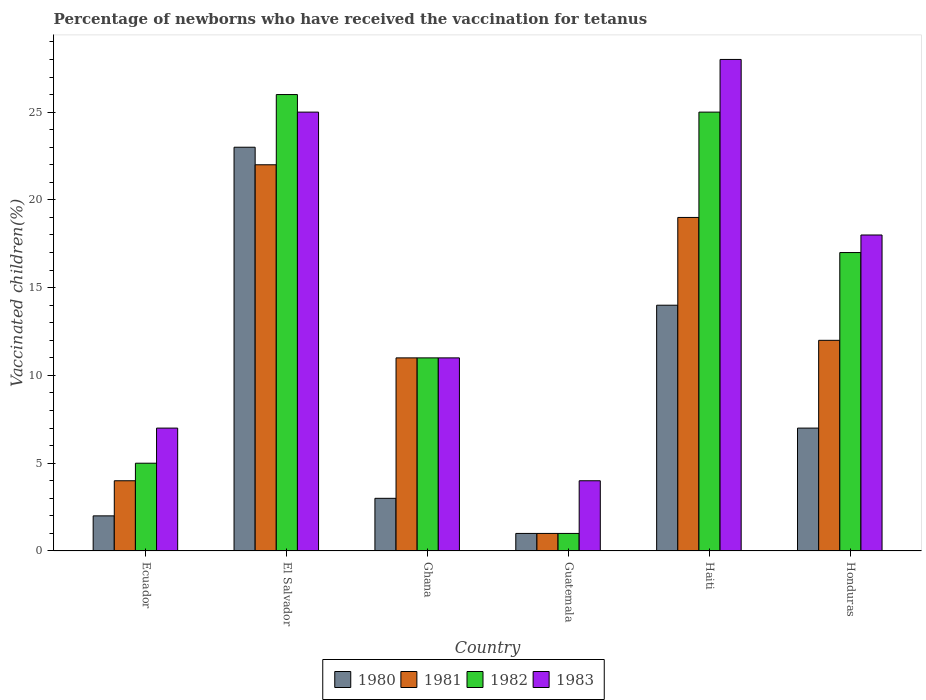How many bars are there on the 6th tick from the left?
Provide a short and direct response. 4. How many bars are there on the 1st tick from the right?
Keep it short and to the point. 4. What is the label of the 1st group of bars from the left?
Your answer should be compact. Ecuador. In which country was the percentage of vaccinated children in 1980 maximum?
Your answer should be very brief. El Salvador. In which country was the percentage of vaccinated children in 1980 minimum?
Your answer should be compact. Guatemala. What is the difference between the percentage of vaccinated children in 1983 in Haiti and that in Honduras?
Provide a succinct answer. 10. What is the average percentage of vaccinated children in 1982 per country?
Give a very brief answer. 14.17. What is the difference between the percentage of vaccinated children of/in 1982 and percentage of vaccinated children of/in 1981 in El Salvador?
Keep it short and to the point. 4. In how many countries, is the percentage of vaccinated children in 1982 greater than 3 %?
Your answer should be very brief. 5. What is the ratio of the percentage of vaccinated children in 1983 in El Salvador to that in Guatemala?
Your answer should be very brief. 6.25. Is the percentage of vaccinated children in 1981 in Haiti less than that in Honduras?
Your response must be concise. No. What is the difference between the highest and the second highest percentage of vaccinated children in 1980?
Make the answer very short. -7. What is the difference between the highest and the lowest percentage of vaccinated children in 1980?
Give a very brief answer. 22. In how many countries, is the percentage of vaccinated children in 1980 greater than the average percentage of vaccinated children in 1980 taken over all countries?
Offer a very short reply. 2. Is it the case that in every country, the sum of the percentage of vaccinated children in 1980 and percentage of vaccinated children in 1981 is greater than the percentage of vaccinated children in 1983?
Make the answer very short. No. What is the difference between two consecutive major ticks on the Y-axis?
Give a very brief answer. 5. Does the graph contain any zero values?
Your response must be concise. No. Does the graph contain grids?
Make the answer very short. No. How many legend labels are there?
Offer a terse response. 4. What is the title of the graph?
Provide a short and direct response. Percentage of newborns who have received the vaccination for tetanus. Does "1961" appear as one of the legend labels in the graph?
Provide a succinct answer. No. What is the label or title of the X-axis?
Your response must be concise. Country. What is the label or title of the Y-axis?
Make the answer very short. Vaccinated children(%). What is the Vaccinated children(%) in 1980 in Ecuador?
Give a very brief answer. 2. What is the Vaccinated children(%) of 1982 in Ecuador?
Provide a short and direct response. 5. What is the Vaccinated children(%) in 1983 in Ecuador?
Offer a terse response. 7. What is the Vaccinated children(%) of 1980 in El Salvador?
Make the answer very short. 23. What is the Vaccinated children(%) of 1982 in Ghana?
Your response must be concise. 11. What is the Vaccinated children(%) in 1980 in Guatemala?
Offer a very short reply. 1. What is the Vaccinated children(%) of 1980 in Haiti?
Your answer should be compact. 14. What is the Vaccinated children(%) of 1981 in Haiti?
Provide a short and direct response. 19. What is the Vaccinated children(%) of 1980 in Honduras?
Your answer should be very brief. 7. What is the Vaccinated children(%) of 1981 in Honduras?
Provide a succinct answer. 12. Across all countries, what is the maximum Vaccinated children(%) of 1980?
Your response must be concise. 23. Across all countries, what is the maximum Vaccinated children(%) in 1981?
Offer a terse response. 22. Across all countries, what is the maximum Vaccinated children(%) of 1982?
Offer a terse response. 26. Across all countries, what is the maximum Vaccinated children(%) of 1983?
Your answer should be very brief. 28. Across all countries, what is the minimum Vaccinated children(%) in 1980?
Provide a short and direct response. 1. Across all countries, what is the minimum Vaccinated children(%) in 1982?
Your answer should be very brief. 1. Across all countries, what is the minimum Vaccinated children(%) in 1983?
Make the answer very short. 4. What is the total Vaccinated children(%) of 1981 in the graph?
Your answer should be compact. 69. What is the total Vaccinated children(%) in 1982 in the graph?
Offer a very short reply. 85. What is the total Vaccinated children(%) in 1983 in the graph?
Your answer should be very brief. 93. What is the difference between the Vaccinated children(%) of 1982 in Ecuador and that in El Salvador?
Your answer should be very brief. -21. What is the difference between the Vaccinated children(%) of 1981 in Ecuador and that in Ghana?
Offer a very short reply. -7. What is the difference between the Vaccinated children(%) of 1982 in Ecuador and that in Ghana?
Your answer should be very brief. -6. What is the difference between the Vaccinated children(%) in 1982 in Ecuador and that in Guatemala?
Make the answer very short. 4. What is the difference between the Vaccinated children(%) of 1981 in Ecuador and that in Haiti?
Provide a short and direct response. -15. What is the difference between the Vaccinated children(%) of 1980 in Ecuador and that in Honduras?
Your answer should be very brief. -5. What is the difference between the Vaccinated children(%) of 1982 in Ecuador and that in Honduras?
Provide a succinct answer. -12. What is the difference between the Vaccinated children(%) of 1981 in El Salvador and that in Ghana?
Make the answer very short. 11. What is the difference between the Vaccinated children(%) of 1982 in El Salvador and that in Ghana?
Your response must be concise. 15. What is the difference between the Vaccinated children(%) of 1983 in El Salvador and that in Ghana?
Your answer should be very brief. 14. What is the difference between the Vaccinated children(%) in 1983 in El Salvador and that in Guatemala?
Make the answer very short. 21. What is the difference between the Vaccinated children(%) in 1980 in El Salvador and that in Haiti?
Ensure brevity in your answer.  9. What is the difference between the Vaccinated children(%) of 1982 in El Salvador and that in Haiti?
Provide a succinct answer. 1. What is the difference between the Vaccinated children(%) of 1983 in El Salvador and that in Haiti?
Offer a terse response. -3. What is the difference between the Vaccinated children(%) of 1983 in El Salvador and that in Honduras?
Keep it short and to the point. 7. What is the difference between the Vaccinated children(%) of 1981 in Ghana and that in Guatemala?
Offer a terse response. 10. What is the difference between the Vaccinated children(%) of 1982 in Ghana and that in Guatemala?
Provide a short and direct response. 10. What is the difference between the Vaccinated children(%) in 1983 in Ghana and that in Guatemala?
Offer a very short reply. 7. What is the difference between the Vaccinated children(%) of 1983 in Ghana and that in Haiti?
Ensure brevity in your answer.  -17. What is the difference between the Vaccinated children(%) in 1980 in Ghana and that in Honduras?
Offer a terse response. -4. What is the difference between the Vaccinated children(%) in 1981 in Ghana and that in Honduras?
Offer a very short reply. -1. What is the difference between the Vaccinated children(%) of 1983 in Ghana and that in Honduras?
Your response must be concise. -7. What is the difference between the Vaccinated children(%) in 1980 in Haiti and that in Honduras?
Your response must be concise. 7. What is the difference between the Vaccinated children(%) in 1982 in Haiti and that in Honduras?
Give a very brief answer. 8. What is the difference between the Vaccinated children(%) in 1983 in Haiti and that in Honduras?
Offer a terse response. 10. What is the difference between the Vaccinated children(%) of 1980 in Ecuador and the Vaccinated children(%) of 1981 in El Salvador?
Offer a very short reply. -20. What is the difference between the Vaccinated children(%) of 1980 in Ecuador and the Vaccinated children(%) of 1982 in El Salvador?
Give a very brief answer. -24. What is the difference between the Vaccinated children(%) of 1981 in Ecuador and the Vaccinated children(%) of 1983 in El Salvador?
Provide a succinct answer. -21. What is the difference between the Vaccinated children(%) of 1980 in Ecuador and the Vaccinated children(%) of 1983 in Ghana?
Your answer should be compact. -9. What is the difference between the Vaccinated children(%) of 1981 in Ecuador and the Vaccinated children(%) of 1982 in Ghana?
Your response must be concise. -7. What is the difference between the Vaccinated children(%) in 1980 in Ecuador and the Vaccinated children(%) in 1983 in Guatemala?
Make the answer very short. -2. What is the difference between the Vaccinated children(%) of 1982 in Ecuador and the Vaccinated children(%) of 1983 in Guatemala?
Your response must be concise. 1. What is the difference between the Vaccinated children(%) of 1980 in Ecuador and the Vaccinated children(%) of 1983 in Haiti?
Provide a short and direct response. -26. What is the difference between the Vaccinated children(%) in 1981 in Ecuador and the Vaccinated children(%) in 1982 in Haiti?
Your answer should be very brief. -21. What is the difference between the Vaccinated children(%) in 1981 in Ecuador and the Vaccinated children(%) in 1983 in Haiti?
Offer a terse response. -24. What is the difference between the Vaccinated children(%) of 1980 in Ecuador and the Vaccinated children(%) of 1983 in Honduras?
Provide a succinct answer. -16. What is the difference between the Vaccinated children(%) in 1981 in Ecuador and the Vaccinated children(%) in 1982 in Honduras?
Offer a terse response. -13. What is the difference between the Vaccinated children(%) of 1981 in Ecuador and the Vaccinated children(%) of 1983 in Honduras?
Give a very brief answer. -14. What is the difference between the Vaccinated children(%) of 1982 in Ecuador and the Vaccinated children(%) of 1983 in Honduras?
Your answer should be very brief. -13. What is the difference between the Vaccinated children(%) in 1980 in El Salvador and the Vaccinated children(%) in 1982 in Guatemala?
Ensure brevity in your answer.  22. What is the difference between the Vaccinated children(%) in 1981 in El Salvador and the Vaccinated children(%) in 1982 in Guatemala?
Your answer should be very brief. 21. What is the difference between the Vaccinated children(%) in 1981 in El Salvador and the Vaccinated children(%) in 1983 in Guatemala?
Your answer should be very brief. 18. What is the difference between the Vaccinated children(%) of 1980 in El Salvador and the Vaccinated children(%) of 1982 in Haiti?
Offer a very short reply. -2. What is the difference between the Vaccinated children(%) of 1982 in El Salvador and the Vaccinated children(%) of 1983 in Haiti?
Keep it short and to the point. -2. What is the difference between the Vaccinated children(%) of 1980 in El Salvador and the Vaccinated children(%) of 1982 in Honduras?
Offer a terse response. 6. What is the difference between the Vaccinated children(%) of 1981 in El Salvador and the Vaccinated children(%) of 1982 in Honduras?
Offer a very short reply. 5. What is the difference between the Vaccinated children(%) of 1980 in Ghana and the Vaccinated children(%) of 1981 in Guatemala?
Your answer should be very brief. 2. What is the difference between the Vaccinated children(%) of 1980 in Ghana and the Vaccinated children(%) of 1982 in Guatemala?
Provide a succinct answer. 2. What is the difference between the Vaccinated children(%) of 1980 in Ghana and the Vaccinated children(%) of 1983 in Guatemala?
Your answer should be very brief. -1. What is the difference between the Vaccinated children(%) in 1980 in Ghana and the Vaccinated children(%) in 1981 in Haiti?
Ensure brevity in your answer.  -16. What is the difference between the Vaccinated children(%) of 1980 in Ghana and the Vaccinated children(%) of 1983 in Haiti?
Your response must be concise. -25. What is the difference between the Vaccinated children(%) of 1981 in Ghana and the Vaccinated children(%) of 1982 in Haiti?
Your response must be concise. -14. What is the difference between the Vaccinated children(%) in 1981 in Ghana and the Vaccinated children(%) in 1983 in Haiti?
Provide a succinct answer. -17. What is the difference between the Vaccinated children(%) in 1982 in Ghana and the Vaccinated children(%) in 1983 in Haiti?
Offer a terse response. -17. What is the difference between the Vaccinated children(%) in 1980 in Ghana and the Vaccinated children(%) in 1981 in Honduras?
Your answer should be compact. -9. What is the difference between the Vaccinated children(%) in 1980 in Ghana and the Vaccinated children(%) in 1982 in Honduras?
Ensure brevity in your answer.  -14. What is the difference between the Vaccinated children(%) of 1980 in Ghana and the Vaccinated children(%) of 1983 in Honduras?
Your answer should be compact. -15. What is the difference between the Vaccinated children(%) in 1981 in Ghana and the Vaccinated children(%) in 1982 in Honduras?
Your answer should be very brief. -6. What is the difference between the Vaccinated children(%) of 1980 in Guatemala and the Vaccinated children(%) of 1981 in Haiti?
Your answer should be very brief. -18. What is the difference between the Vaccinated children(%) in 1981 in Guatemala and the Vaccinated children(%) in 1983 in Haiti?
Keep it short and to the point. -27. What is the difference between the Vaccinated children(%) of 1982 in Guatemala and the Vaccinated children(%) of 1983 in Haiti?
Keep it short and to the point. -27. What is the difference between the Vaccinated children(%) of 1980 in Guatemala and the Vaccinated children(%) of 1981 in Honduras?
Your answer should be very brief. -11. What is the difference between the Vaccinated children(%) in 1980 in Guatemala and the Vaccinated children(%) in 1982 in Honduras?
Your answer should be compact. -16. What is the difference between the Vaccinated children(%) in 1980 in Haiti and the Vaccinated children(%) in 1981 in Honduras?
Keep it short and to the point. 2. What is the difference between the Vaccinated children(%) of 1980 in Haiti and the Vaccinated children(%) of 1982 in Honduras?
Offer a very short reply. -3. What is the difference between the Vaccinated children(%) of 1980 in Haiti and the Vaccinated children(%) of 1983 in Honduras?
Provide a short and direct response. -4. What is the difference between the Vaccinated children(%) in 1981 in Haiti and the Vaccinated children(%) in 1983 in Honduras?
Offer a very short reply. 1. What is the difference between the Vaccinated children(%) of 1982 in Haiti and the Vaccinated children(%) of 1983 in Honduras?
Give a very brief answer. 7. What is the average Vaccinated children(%) of 1980 per country?
Keep it short and to the point. 8.33. What is the average Vaccinated children(%) of 1981 per country?
Your answer should be very brief. 11.5. What is the average Vaccinated children(%) of 1982 per country?
Ensure brevity in your answer.  14.17. What is the average Vaccinated children(%) of 1983 per country?
Provide a short and direct response. 15.5. What is the difference between the Vaccinated children(%) of 1980 and Vaccinated children(%) of 1981 in Ecuador?
Ensure brevity in your answer.  -2. What is the difference between the Vaccinated children(%) in 1980 and Vaccinated children(%) in 1983 in Ecuador?
Keep it short and to the point. -5. What is the difference between the Vaccinated children(%) of 1981 and Vaccinated children(%) of 1982 in Ecuador?
Provide a short and direct response. -1. What is the difference between the Vaccinated children(%) of 1982 and Vaccinated children(%) of 1983 in Ecuador?
Provide a succinct answer. -2. What is the difference between the Vaccinated children(%) of 1980 and Vaccinated children(%) of 1981 in El Salvador?
Make the answer very short. 1. What is the difference between the Vaccinated children(%) of 1980 and Vaccinated children(%) of 1982 in Ghana?
Make the answer very short. -8. What is the difference between the Vaccinated children(%) in 1980 and Vaccinated children(%) in 1983 in Ghana?
Keep it short and to the point. -8. What is the difference between the Vaccinated children(%) of 1981 and Vaccinated children(%) of 1983 in Ghana?
Ensure brevity in your answer.  0. What is the difference between the Vaccinated children(%) in 1982 and Vaccinated children(%) in 1983 in Ghana?
Keep it short and to the point. 0. What is the difference between the Vaccinated children(%) of 1980 and Vaccinated children(%) of 1982 in Guatemala?
Keep it short and to the point. 0. What is the difference between the Vaccinated children(%) in 1981 and Vaccinated children(%) in 1982 in Guatemala?
Give a very brief answer. 0. What is the difference between the Vaccinated children(%) of 1982 and Vaccinated children(%) of 1983 in Guatemala?
Give a very brief answer. -3. What is the difference between the Vaccinated children(%) in 1980 and Vaccinated children(%) in 1981 in Haiti?
Provide a succinct answer. -5. What is the difference between the Vaccinated children(%) in 1980 and Vaccinated children(%) in 1983 in Haiti?
Your response must be concise. -14. What is the difference between the Vaccinated children(%) in 1982 and Vaccinated children(%) in 1983 in Haiti?
Provide a short and direct response. -3. What is the difference between the Vaccinated children(%) in 1980 and Vaccinated children(%) in 1983 in Honduras?
Make the answer very short. -11. What is the difference between the Vaccinated children(%) in 1981 and Vaccinated children(%) in 1982 in Honduras?
Your answer should be compact. -5. What is the difference between the Vaccinated children(%) in 1981 and Vaccinated children(%) in 1983 in Honduras?
Keep it short and to the point. -6. What is the difference between the Vaccinated children(%) of 1982 and Vaccinated children(%) of 1983 in Honduras?
Offer a terse response. -1. What is the ratio of the Vaccinated children(%) in 1980 in Ecuador to that in El Salvador?
Your response must be concise. 0.09. What is the ratio of the Vaccinated children(%) in 1981 in Ecuador to that in El Salvador?
Ensure brevity in your answer.  0.18. What is the ratio of the Vaccinated children(%) in 1982 in Ecuador to that in El Salvador?
Offer a very short reply. 0.19. What is the ratio of the Vaccinated children(%) of 1983 in Ecuador to that in El Salvador?
Provide a succinct answer. 0.28. What is the ratio of the Vaccinated children(%) of 1981 in Ecuador to that in Ghana?
Your answer should be very brief. 0.36. What is the ratio of the Vaccinated children(%) of 1982 in Ecuador to that in Ghana?
Offer a very short reply. 0.45. What is the ratio of the Vaccinated children(%) in 1983 in Ecuador to that in Ghana?
Offer a terse response. 0.64. What is the ratio of the Vaccinated children(%) in 1980 in Ecuador to that in Guatemala?
Give a very brief answer. 2. What is the ratio of the Vaccinated children(%) of 1983 in Ecuador to that in Guatemala?
Provide a succinct answer. 1.75. What is the ratio of the Vaccinated children(%) of 1980 in Ecuador to that in Haiti?
Offer a very short reply. 0.14. What is the ratio of the Vaccinated children(%) of 1981 in Ecuador to that in Haiti?
Offer a terse response. 0.21. What is the ratio of the Vaccinated children(%) in 1982 in Ecuador to that in Haiti?
Offer a very short reply. 0.2. What is the ratio of the Vaccinated children(%) of 1983 in Ecuador to that in Haiti?
Offer a very short reply. 0.25. What is the ratio of the Vaccinated children(%) of 1980 in Ecuador to that in Honduras?
Offer a very short reply. 0.29. What is the ratio of the Vaccinated children(%) of 1981 in Ecuador to that in Honduras?
Your response must be concise. 0.33. What is the ratio of the Vaccinated children(%) in 1982 in Ecuador to that in Honduras?
Provide a short and direct response. 0.29. What is the ratio of the Vaccinated children(%) in 1983 in Ecuador to that in Honduras?
Offer a terse response. 0.39. What is the ratio of the Vaccinated children(%) in 1980 in El Salvador to that in Ghana?
Your answer should be compact. 7.67. What is the ratio of the Vaccinated children(%) in 1982 in El Salvador to that in Ghana?
Your answer should be very brief. 2.36. What is the ratio of the Vaccinated children(%) of 1983 in El Salvador to that in Ghana?
Offer a terse response. 2.27. What is the ratio of the Vaccinated children(%) in 1980 in El Salvador to that in Guatemala?
Offer a terse response. 23. What is the ratio of the Vaccinated children(%) in 1983 in El Salvador to that in Guatemala?
Ensure brevity in your answer.  6.25. What is the ratio of the Vaccinated children(%) in 1980 in El Salvador to that in Haiti?
Ensure brevity in your answer.  1.64. What is the ratio of the Vaccinated children(%) of 1981 in El Salvador to that in Haiti?
Offer a terse response. 1.16. What is the ratio of the Vaccinated children(%) of 1982 in El Salvador to that in Haiti?
Provide a succinct answer. 1.04. What is the ratio of the Vaccinated children(%) in 1983 in El Salvador to that in Haiti?
Provide a short and direct response. 0.89. What is the ratio of the Vaccinated children(%) in 1980 in El Salvador to that in Honduras?
Give a very brief answer. 3.29. What is the ratio of the Vaccinated children(%) in 1981 in El Salvador to that in Honduras?
Give a very brief answer. 1.83. What is the ratio of the Vaccinated children(%) in 1982 in El Salvador to that in Honduras?
Offer a terse response. 1.53. What is the ratio of the Vaccinated children(%) in 1983 in El Salvador to that in Honduras?
Provide a succinct answer. 1.39. What is the ratio of the Vaccinated children(%) of 1980 in Ghana to that in Guatemala?
Your answer should be compact. 3. What is the ratio of the Vaccinated children(%) of 1981 in Ghana to that in Guatemala?
Keep it short and to the point. 11. What is the ratio of the Vaccinated children(%) of 1983 in Ghana to that in Guatemala?
Provide a succinct answer. 2.75. What is the ratio of the Vaccinated children(%) in 1980 in Ghana to that in Haiti?
Offer a very short reply. 0.21. What is the ratio of the Vaccinated children(%) in 1981 in Ghana to that in Haiti?
Offer a very short reply. 0.58. What is the ratio of the Vaccinated children(%) of 1982 in Ghana to that in Haiti?
Offer a terse response. 0.44. What is the ratio of the Vaccinated children(%) in 1983 in Ghana to that in Haiti?
Your answer should be compact. 0.39. What is the ratio of the Vaccinated children(%) in 1980 in Ghana to that in Honduras?
Your answer should be very brief. 0.43. What is the ratio of the Vaccinated children(%) in 1982 in Ghana to that in Honduras?
Make the answer very short. 0.65. What is the ratio of the Vaccinated children(%) in 1983 in Ghana to that in Honduras?
Offer a terse response. 0.61. What is the ratio of the Vaccinated children(%) in 1980 in Guatemala to that in Haiti?
Keep it short and to the point. 0.07. What is the ratio of the Vaccinated children(%) of 1981 in Guatemala to that in Haiti?
Your answer should be very brief. 0.05. What is the ratio of the Vaccinated children(%) in 1982 in Guatemala to that in Haiti?
Your answer should be compact. 0.04. What is the ratio of the Vaccinated children(%) of 1983 in Guatemala to that in Haiti?
Give a very brief answer. 0.14. What is the ratio of the Vaccinated children(%) in 1980 in Guatemala to that in Honduras?
Make the answer very short. 0.14. What is the ratio of the Vaccinated children(%) in 1981 in Guatemala to that in Honduras?
Provide a short and direct response. 0.08. What is the ratio of the Vaccinated children(%) of 1982 in Guatemala to that in Honduras?
Offer a terse response. 0.06. What is the ratio of the Vaccinated children(%) in 1983 in Guatemala to that in Honduras?
Make the answer very short. 0.22. What is the ratio of the Vaccinated children(%) in 1980 in Haiti to that in Honduras?
Your answer should be very brief. 2. What is the ratio of the Vaccinated children(%) of 1981 in Haiti to that in Honduras?
Your answer should be very brief. 1.58. What is the ratio of the Vaccinated children(%) of 1982 in Haiti to that in Honduras?
Offer a terse response. 1.47. What is the ratio of the Vaccinated children(%) of 1983 in Haiti to that in Honduras?
Provide a succinct answer. 1.56. What is the difference between the highest and the second highest Vaccinated children(%) in 1980?
Offer a terse response. 9. What is the difference between the highest and the second highest Vaccinated children(%) in 1983?
Provide a short and direct response. 3. What is the difference between the highest and the lowest Vaccinated children(%) of 1980?
Give a very brief answer. 22. What is the difference between the highest and the lowest Vaccinated children(%) in 1983?
Your answer should be compact. 24. 